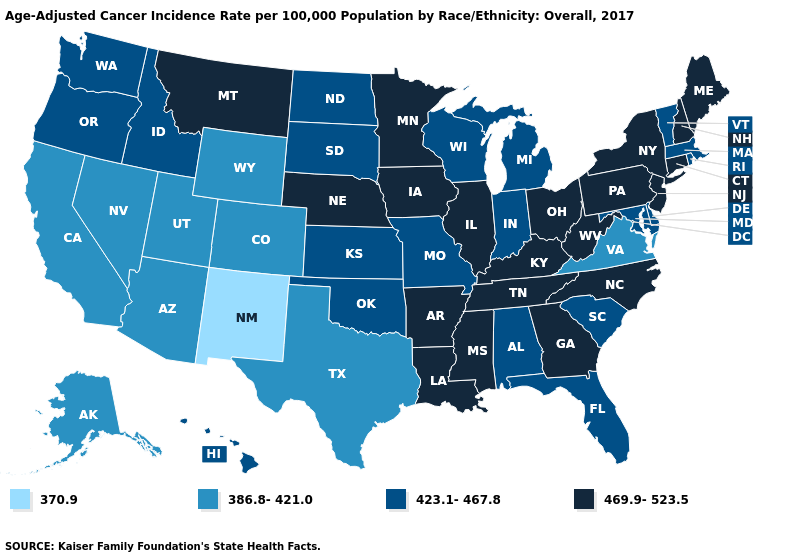What is the highest value in the USA?
Be succinct. 469.9-523.5. Name the states that have a value in the range 469.9-523.5?
Quick response, please. Arkansas, Connecticut, Georgia, Illinois, Iowa, Kentucky, Louisiana, Maine, Minnesota, Mississippi, Montana, Nebraska, New Hampshire, New Jersey, New York, North Carolina, Ohio, Pennsylvania, Tennessee, West Virginia. Name the states that have a value in the range 386.8-421.0?
Be succinct. Alaska, Arizona, California, Colorado, Nevada, Texas, Utah, Virginia, Wyoming. Among the states that border Arizona , which have the highest value?
Concise answer only. California, Colorado, Nevada, Utah. Does South Dakota have the same value as Texas?
Concise answer only. No. Which states hav the highest value in the West?
Short answer required. Montana. Name the states that have a value in the range 423.1-467.8?
Answer briefly. Alabama, Delaware, Florida, Hawaii, Idaho, Indiana, Kansas, Maryland, Massachusetts, Michigan, Missouri, North Dakota, Oklahoma, Oregon, Rhode Island, South Carolina, South Dakota, Vermont, Washington, Wisconsin. Among the states that border New Jersey , does New York have the highest value?
Write a very short answer. Yes. Does New Mexico have the lowest value in the USA?
Write a very short answer. Yes. Which states hav the highest value in the Northeast?
Concise answer only. Connecticut, Maine, New Hampshire, New Jersey, New York, Pennsylvania. What is the value of Tennessee?
Concise answer only. 469.9-523.5. What is the lowest value in the USA?
Write a very short answer. 370.9. What is the lowest value in states that border Florida?
Answer briefly. 423.1-467.8. Does the map have missing data?
Short answer required. No. What is the value of Utah?
Answer briefly. 386.8-421.0. 